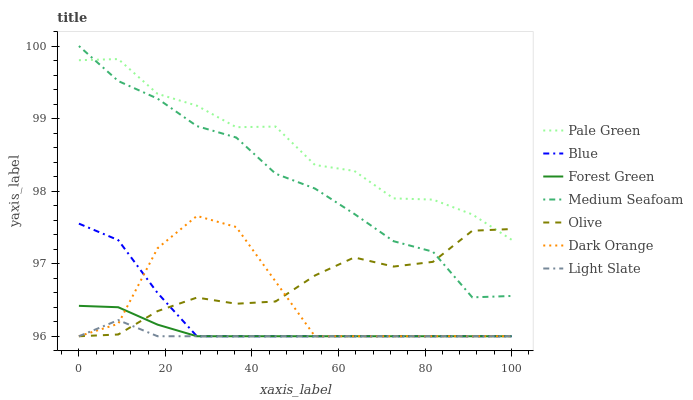Does Light Slate have the minimum area under the curve?
Answer yes or no. Yes. Does Pale Green have the maximum area under the curve?
Answer yes or no. Yes. Does Dark Orange have the minimum area under the curve?
Answer yes or no. No. Does Dark Orange have the maximum area under the curve?
Answer yes or no. No. Is Forest Green the smoothest?
Answer yes or no. Yes. Is Dark Orange the roughest?
Answer yes or no. Yes. Is Light Slate the smoothest?
Answer yes or no. No. Is Light Slate the roughest?
Answer yes or no. No. Does Blue have the lowest value?
Answer yes or no. Yes. Does Pale Green have the lowest value?
Answer yes or no. No. Does Medium Seafoam have the highest value?
Answer yes or no. Yes. Does Dark Orange have the highest value?
Answer yes or no. No. Is Light Slate less than Medium Seafoam?
Answer yes or no. Yes. Is Medium Seafoam greater than Dark Orange?
Answer yes or no. Yes. Does Forest Green intersect Olive?
Answer yes or no. Yes. Is Forest Green less than Olive?
Answer yes or no. No. Is Forest Green greater than Olive?
Answer yes or no. No. Does Light Slate intersect Medium Seafoam?
Answer yes or no. No. 